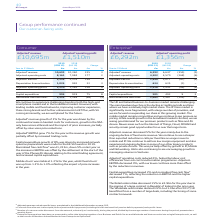According to Bt Group Plc's financial document, What was the Adjusted revenue change? According to the financial document, 3%. The relevant text states: "Adjusted a revenue growth of 3% for the year was driven by the continued increase in handset costs for customers, growth in the SIM-..." Also, What was the Adjusted EBITDA change? According to the financial document, 7%. The relevant text states: "Adjusted a EBITDA grew 7% for the year as the revenue growth was partially offset by increased trading costs...." Also, What was the reason for capital expenditure growth? driven by increased network spend as preparations were made for the EE 5G launch in 2019.. The document states: "Capital expenditure growth of 8% was driven by increased network spend as preparations were made for the EE 5G launch in 2019. Normalised free cash fl..." Also, can you calculate: What was the average Adjusted EBITDA for 2018 and 2019? To answer this question, I need to perform calculations using the financial data. The calculation is: (2,534 + 2,376) / 2, which equals 2455 (in millions). This is based on the information: "Adjusted a EBITDA 2,534 2,376 158 7 Adjusted a EBITDA 2,534 2,376 158 7..." The key data points involved are: 2,376, 2,534. Also, can you calculate: What  was the EBITDA margin in 2019? Based on the calculation: 2,534 / 10,695, the result is 0.24. This is based on the information: "Adjusted a EBITDA 2,534 2,376 158 7 Adjusted a revenue 10,695 10,360 335 3..." The key data points involved are: 10,695, 2,534. Also, can you calculate: What is the average Adjusteda operating costs for 2018 and 2019? To answer this question, I need to perform calculations using the financial data. The calculation is: (8,161 + 7,984) / 2, which equals 8072.5 (in millions). This is based on the information: "Adjusted a operating costs 8,161 7,984 177 2 Adjusted a operating costs 8,161 7,984 177 2..." The key data points involved are: 7,984, 8,161. 